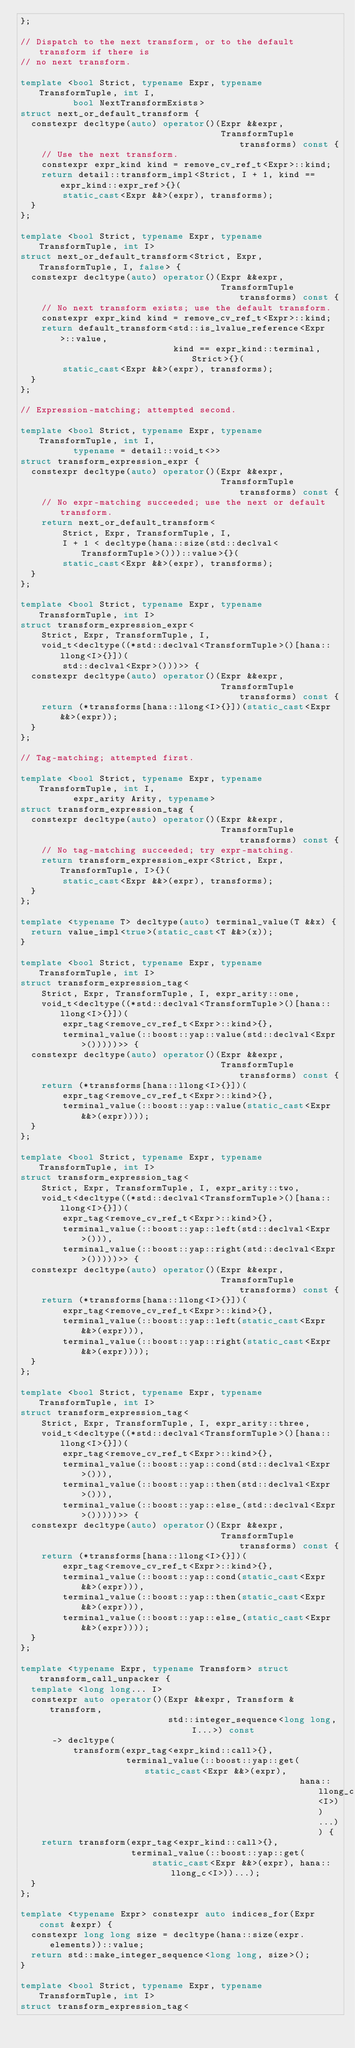<code> <loc_0><loc_0><loc_500><loc_500><_C++_>};

// Dispatch to the next transform, or to the default transform if there is
// no next transform.

template <bool Strict, typename Expr, typename TransformTuple, int I,
          bool NextTransformExists>
struct next_or_default_transform {
  constexpr decltype(auto) operator()(Expr &&expr,
                                      TransformTuple transforms) const {
    // Use the next transform.
    constexpr expr_kind kind = remove_cv_ref_t<Expr>::kind;
    return detail::transform_impl<Strict, I + 1, kind == expr_kind::expr_ref>{}(
        static_cast<Expr &&>(expr), transforms);
  }
};

template <bool Strict, typename Expr, typename TransformTuple, int I>
struct next_or_default_transform<Strict, Expr, TransformTuple, I, false> {
  constexpr decltype(auto) operator()(Expr &&expr,
                                      TransformTuple transforms) const {
    // No next transform exists; use the default transform.
    constexpr expr_kind kind = remove_cv_ref_t<Expr>::kind;
    return default_transform<std::is_lvalue_reference<Expr>::value,
                             kind == expr_kind::terminal, Strict>{}(
        static_cast<Expr &&>(expr), transforms);
  }
};

// Expression-matching; attempted second.

template <bool Strict, typename Expr, typename TransformTuple, int I,
          typename = detail::void_t<>>
struct transform_expression_expr {
  constexpr decltype(auto) operator()(Expr &&expr,
                                      TransformTuple transforms) const {
    // No expr-matching succeeded; use the next or default transform.
    return next_or_default_transform<
        Strict, Expr, TransformTuple, I,
        I + 1 < decltype(hana::size(std::declval<TransformTuple>()))::value>{}(
        static_cast<Expr &&>(expr), transforms);
  }
};

template <bool Strict, typename Expr, typename TransformTuple, int I>
struct transform_expression_expr<
    Strict, Expr, TransformTuple, I,
    void_t<decltype((*std::declval<TransformTuple>()[hana::llong<I>{}])(
        std::declval<Expr>()))>> {
  constexpr decltype(auto) operator()(Expr &&expr,
                                      TransformTuple transforms) const {
    return (*transforms[hana::llong<I>{}])(static_cast<Expr &&>(expr));
  }
};

// Tag-matching; attempted first.

template <bool Strict, typename Expr, typename TransformTuple, int I,
          expr_arity Arity, typename>
struct transform_expression_tag {
  constexpr decltype(auto) operator()(Expr &&expr,
                                      TransformTuple transforms) const {
    // No tag-matching succeeded; try expr-matching.
    return transform_expression_expr<Strict, Expr, TransformTuple, I>{}(
        static_cast<Expr &&>(expr), transforms);
  }
};

template <typename T> decltype(auto) terminal_value(T &&x) {
  return value_impl<true>(static_cast<T &&>(x));
}

template <bool Strict, typename Expr, typename TransformTuple, int I>
struct transform_expression_tag<
    Strict, Expr, TransformTuple, I, expr_arity::one,
    void_t<decltype((*std::declval<TransformTuple>()[hana::llong<I>{}])(
        expr_tag<remove_cv_ref_t<Expr>::kind>{},
        terminal_value(::boost::yap::value(std::declval<Expr>()))))>> {
  constexpr decltype(auto) operator()(Expr &&expr,
                                      TransformTuple transforms) const {
    return (*transforms[hana::llong<I>{}])(
        expr_tag<remove_cv_ref_t<Expr>::kind>{},
        terminal_value(::boost::yap::value(static_cast<Expr &&>(expr))));
  }
};

template <bool Strict, typename Expr, typename TransformTuple, int I>
struct transform_expression_tag<
    Strict, Expr, TransformTuple, I, expr_arity::two,
    void_t<decltype((*std::declval<TransformTuple>()[hana::llong<I>{}])(
        expr_tag<remove_cv_ref_t<Expr>::kind>{},
        terminal_value(::boost::yap::left(std::declval<Expr>())),
        terminal_value(::boost::yap::right(std::declval<Expr>()))))>> {
  constexpr decltype(auto) operator()(Expr &&expr,
                                      TransformTuple transforms) const {
    return (*transforms[hana::llong<I>{}])(
        expr_tag<remove_cv_ref_t<Expr>::kind>{},
        terminal_value(::boost::yap::left(static_cast<Expr &&>(expr))),
        terminal_value(::boost::yap::right(static_cast<Expr &&>(expr))));
  }
};

template <bool Strict, typename Expr, typename TransformTuple, int I>
struct transform_expression_tag<
    Strict, Expr, TransformTuple, I, expr_arity::three,
    void_t<decltype((*std::declval<TransformTuple>()[hana::llong<I>{}])(
        expr_tag<remove_cv_ref_t<Expr>::kind>{},
        terminal_value(::boost::yap::cond(std::declval<Expr>())),
        terminal_value(::boost::yap::then(std::declval<Expr>())),
        terminal_value(::boost::yap::else_(std::declval<Expr>()))))>> {
  constexpr decltype(auto) operator()(Expr &&expr,
                                      TransformTuple transforms) const {
    return (*transforms[hana::llong<I>{}])(
        expr_tag<remove_cv_ref_t<Expr>::kind>{},
        terminal_value(::boost::yap::cond(static_cast<Expr &&>(expr))),
        terminal_value(::boost::yap::then(static_cast<Expr &&>(expr))),
        terminal_value(::boost::yap::else_(static_cast<Expr &&>(expr))));
  }
};

template <typename Expr, typename Transform> struct transform_call_unpacker {
  template <long long... I>
  constexpr auto operator()(Expr &&expr, Transform &transform,
                            std::integer_sequence<long long, I...>) const
      -> decltype(
          transform(expr_tag<expr_kind::call>{},
                    terminal_value(::boost::yap::get(static_cast<Expr &&>(expr),
                                                     hana::llong_c<I>))...)) {
    return transform(expr_tag<expr_kind::call>{},
                     terminal_value(::boost::yap::get(
                         static_cast<Expr &&>(expr), hana::llong_c<I>))...);
  }
};

template <typename Expr> constexpr auto indices_for(Expr const &expr) {
  constexpr long long size = decltype(hana::size(expr.elements))::value;
  return std::make_integer_sequence<long long, size>();
}

template <bool Strict, typename Expr, typename TransformTuple, int I>
struct transform_expression_tag<</code> 